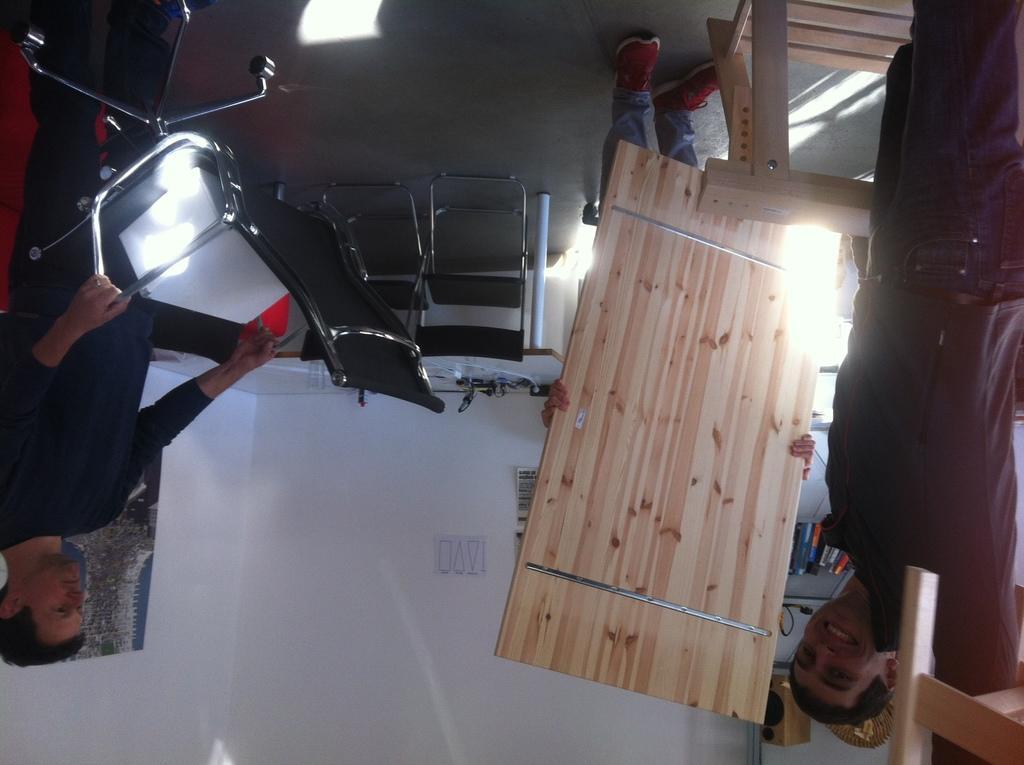In one or two sentences, can you explain what this image depicts? These two persons are standing. This person is holding a chair. Far another person is standing and holding this board. A poster and picture on wall. This cupboard is filled with books and speaker. This man is smiling. 